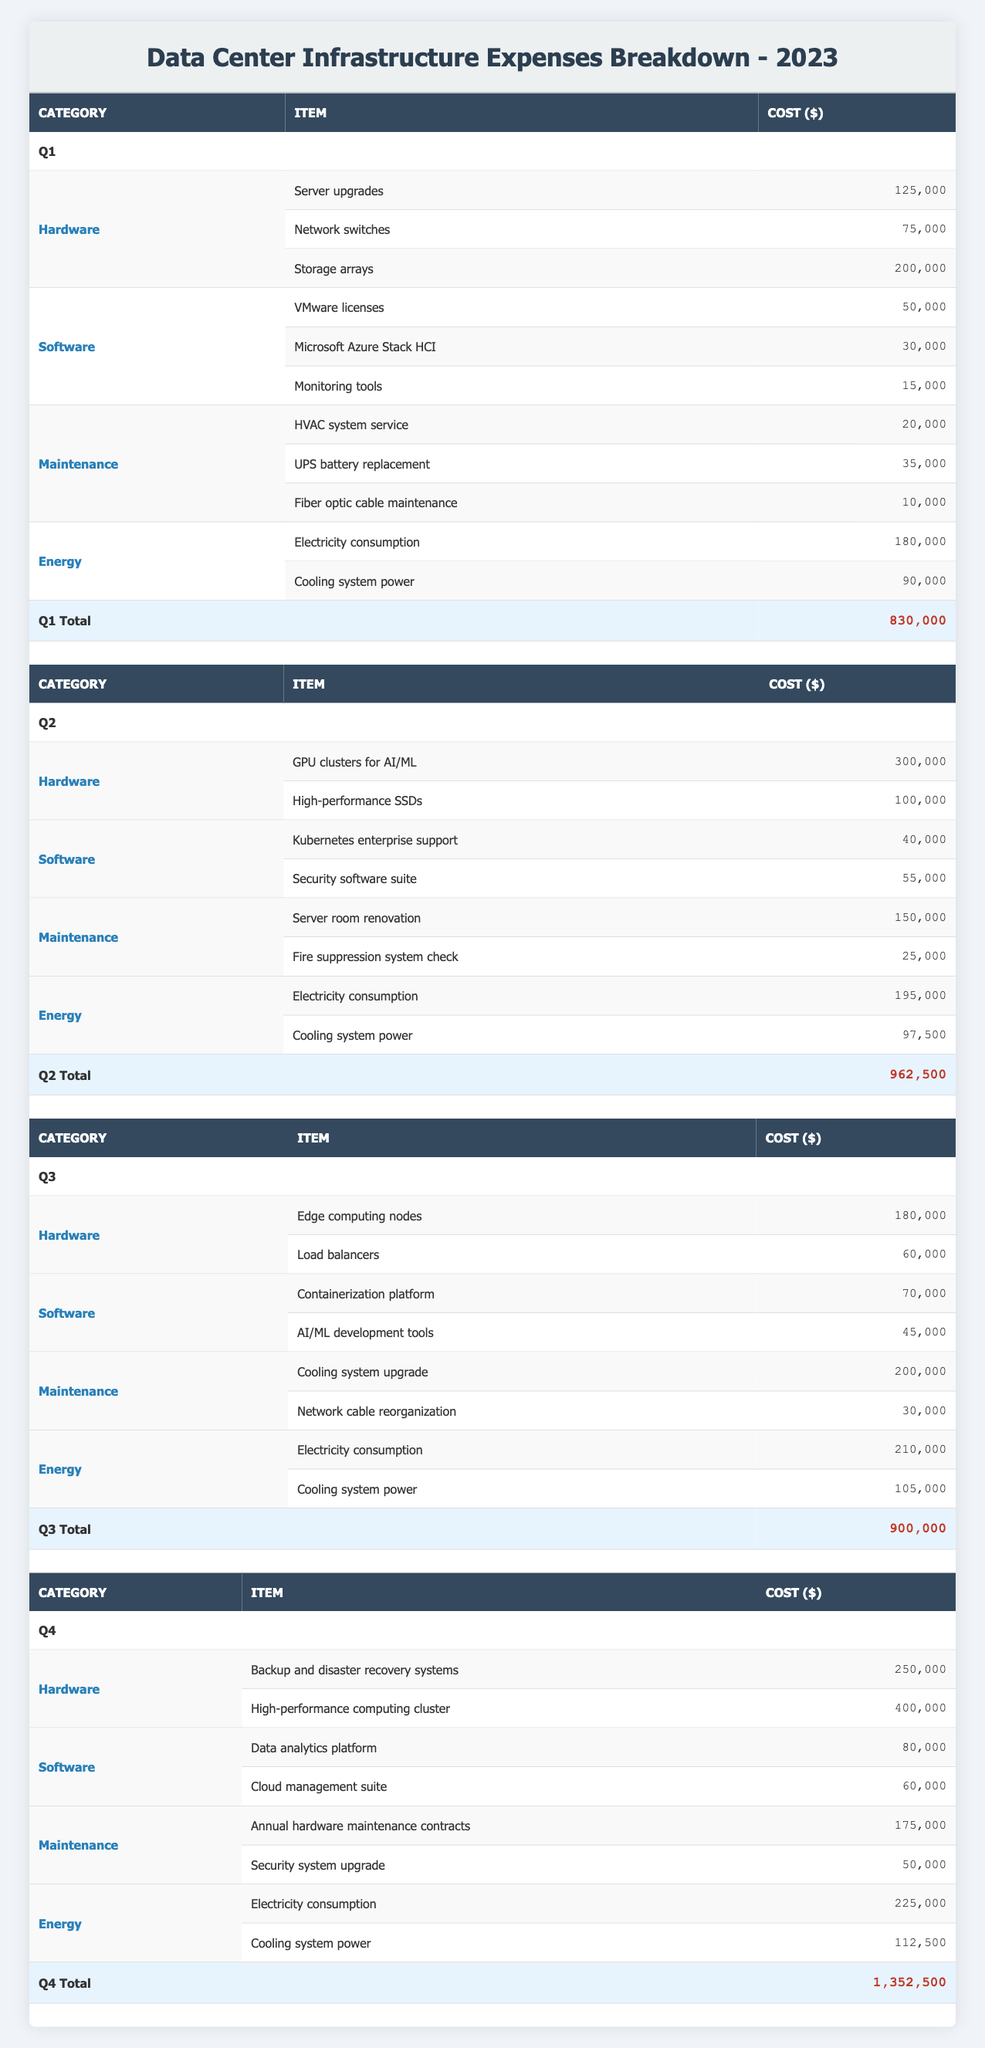What were the total expenses for Q3? To find the total expenses for Q3, we refer to the Q3 total row in the table, which lists the total expenses for that quarter. It shows a total of 900,000 dollars.
Answer: 900,000 Which quarter had the highest energy expenses? In each quarter, the expenses for energy can be summed up from the respective rows. For Q1, it's 270,000; for Q2, it's 292,500; for Q3, it's 315,000; and for Q4, it's 337,500. The maximum energy expense is for Q4.
Answer: Q4 How much was spent on hardware in Q4? Referring to the Q4 hardware expenses, we see two items: backup and disaster recovery systems for 250,000 and high-performance computing cluster for 400,000. Their sum is 650,000.
Answer: 650,000 Did Q2 have higher software expenses than Q3? We compare the total software expenses for both quarters. In Q2, the total is 95,000, while in Q3, the total is 115,000. Since 95,000 is less than 115,000, the answer is No.
Answer: No What is the average cost of the maintenance expenses across all quarters? The maintenance expenses for each quarter can be summed: Q1 is 65,000, Q2 is 175,000, Q3 is 230,000, and Q4 is 225,000. Their total is 695,000. Since there are four quarters, the average is 695,000 divided by 4, which equals 173,750.
Answer: 173,750 How much was spent on electricity across all four quarters? The electricity expenses for each quarter are as follows: Q1 is 180,000, Q2 is 195,000, Q3 is 210,000, and Q4 is 225,000. Summing these gives a total of 1,010,000 dollars.
Answer: 1,010,000 Which category had the highest total expenditures for the year? First, we need to compute the total for each category across all quarters. The hardware total is 1,335,000, software total is 280,000, maintenance total is 695,000, and energy total is 1,115,000. The highest expense is in the hardware category.
Answer: Hardware Were the total expenses in Q1 and Q4 combined greater than the total for Q3? We calculate the combined total for Q1 (830,000) and Q4 (1,352,500) which totals 2,182,500. The Q3 total is 900,000. Since 2,182,500 is greater than 900,000, the answer is Yes.
Answer: Yes 